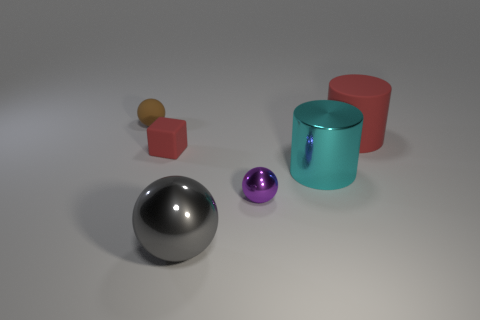Is the shape of the large rubber thing the same as the big object that is on the left side of the metal cylinder?
Keep it short and to the point. No. Are there any other things that are the same material as the small red object?
Give a very brief answer. Yes. There is another thing that is the same shape as the big red object; what is its material?
Ensure brevity in your answer.  Metal. How many large objects are either gray metal blocks or purple spheres?
Make the answer very short. 0. Is the number of small purple metal balls behind the large gray object less than the number of big red objects in front of the red rubber cylinder?
Offer a very short reply. No. What number of things are either small cyan metallic blocks or small rubber blocks?
Your answer should be compact. 1. How many tiny red matte objects are right of the large metallic sphere?
Offer a terse response. 0. Do the big rubber cylinder and the block have the same color?
Make the answer very short. Yes. There is a gray thing that is the same material as the big cyan cylinder; what is its shape?
Make the answer very short. Sphere. There is a large red matte thing behind the large cyan shiny object; does it have the same shape as the big gray metal object?
Ensure brevity in your answer.  No. 